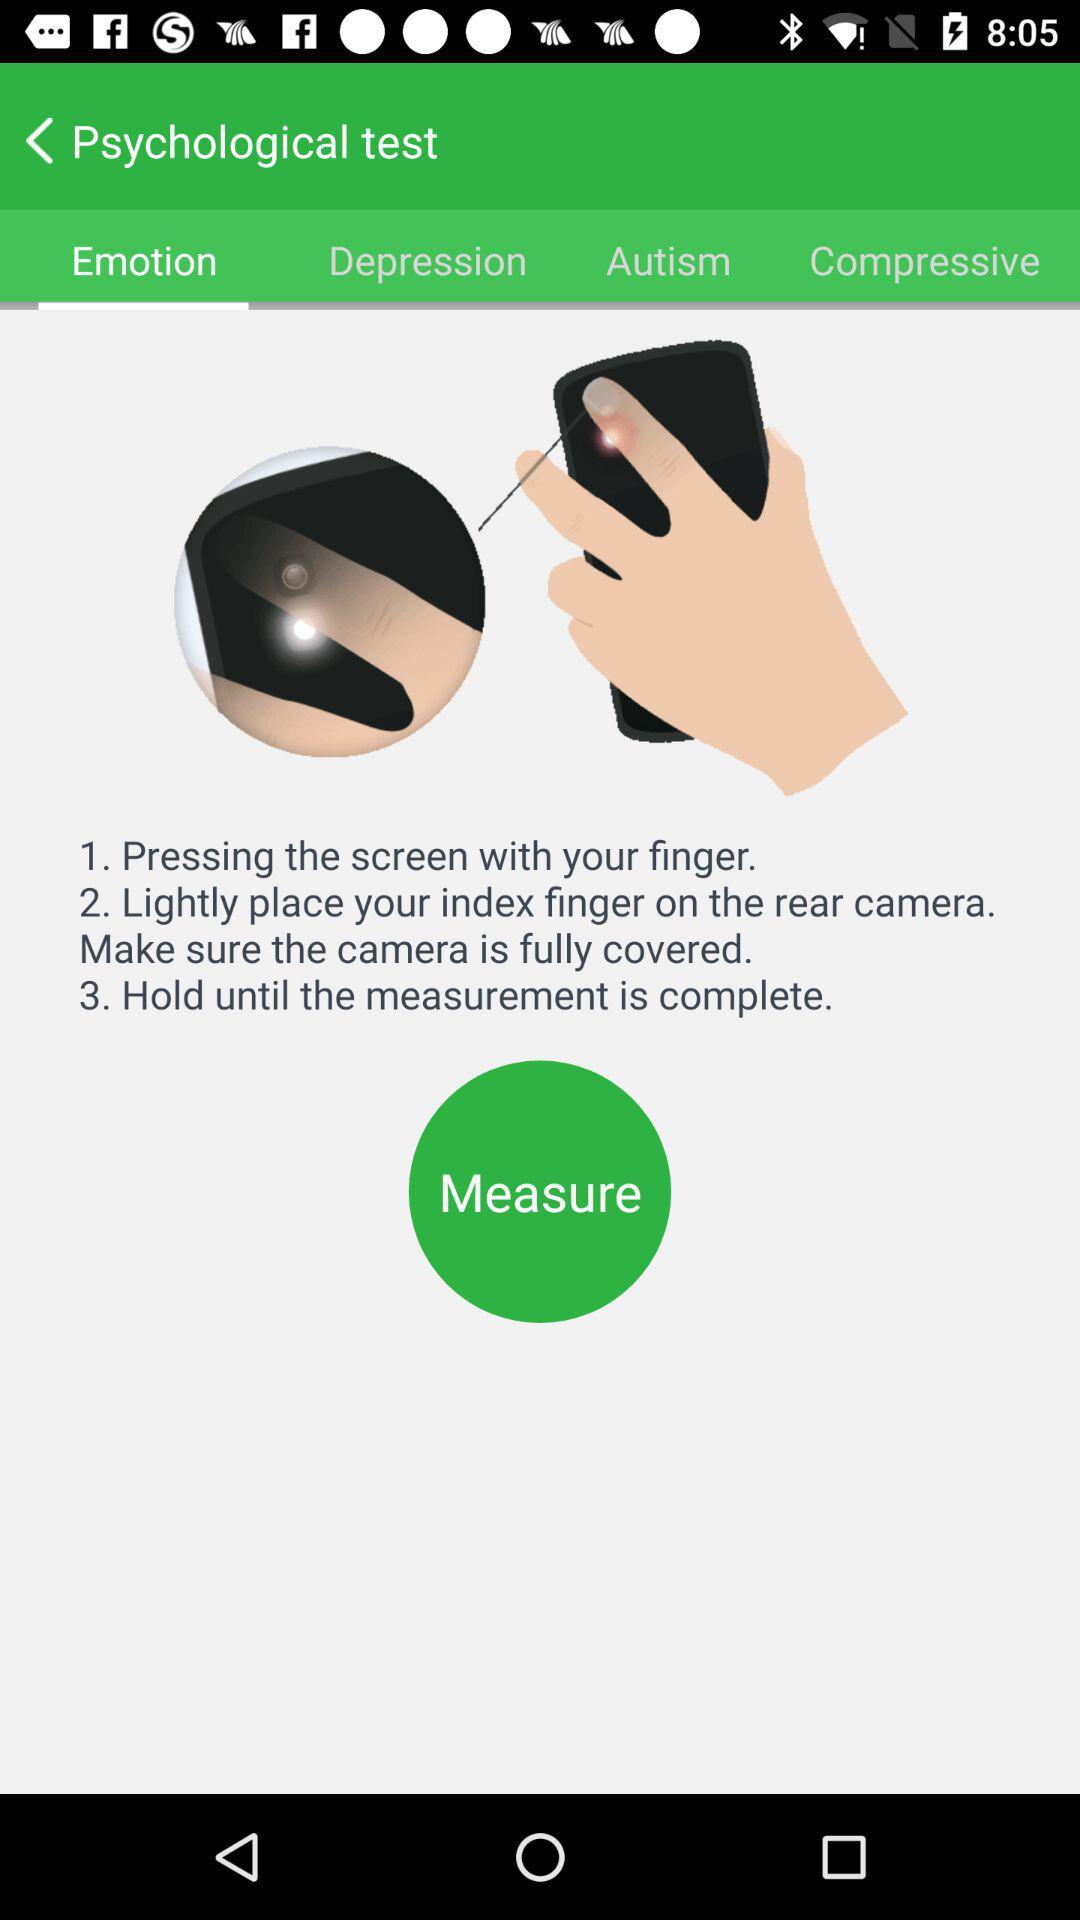Which tab is selected? The selected tab is "Emotion". 